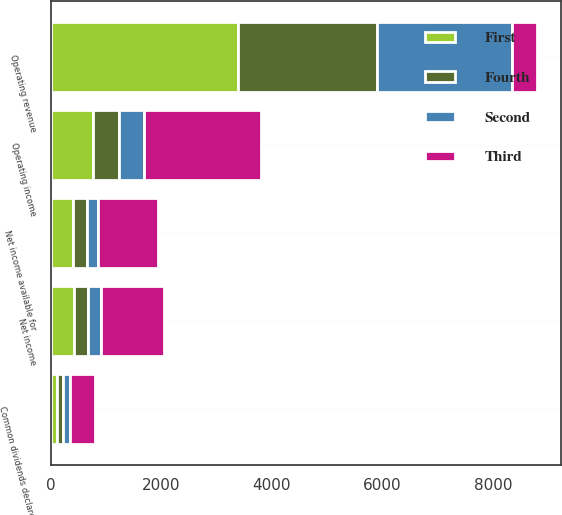Convert chart to OTSL. <chart><loc_0><loc_0><loc_500><loc_500><stacked_bar_chart><ecel><fcel>Operating revenue<fcel>Operating income<fcel>Net income<fcel>Net income available for<fcel>Common dividends declared<nl><fcel>Third<fcel>443<fcel>2123<fcel>1144<fcel>1085<fcel>461<nl><fcel>Fourth<fcel>2514<fcel>474<fcel>262<fcel>247<fcel>116<nl><fcel>First<fcel>3386<fcel>764<fcel>421<fcel>406<fcel>115<nl><fcel>Second<fcel>2446<fcel>443<fcel>226<fcel>211<fcel>115<nl></chart> 